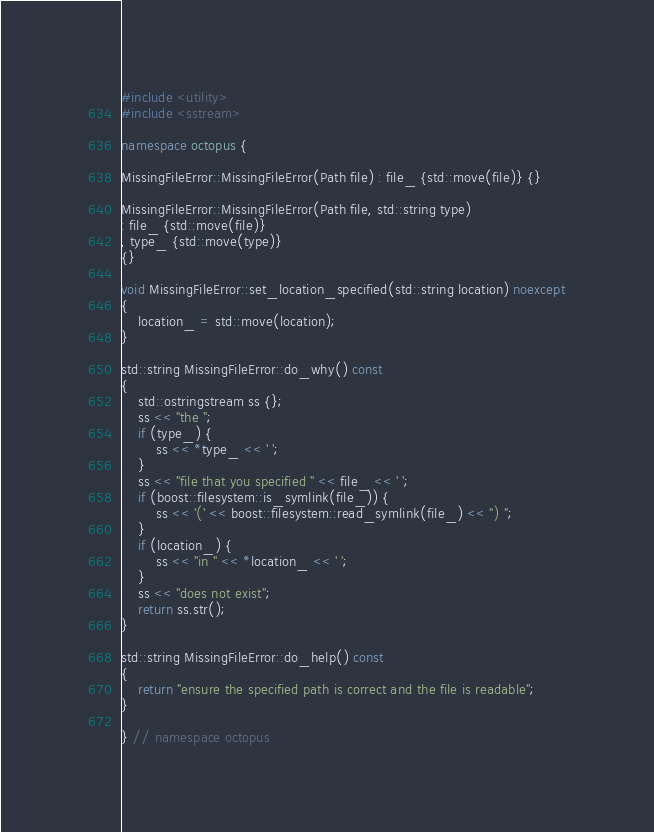Convert code to text. <code><loc_0><loc_0><loc_500><loc_500><_C++_>#include <utility>
#include <sstream>

namespace octopus {

MissingFileError::MissingFileError(Path file) : file_ {std::move(file)} {}

MissingFileError::MissingFileError(Path file, std::string type)
: file_ {std::move(file)}
, type_ {std::move(type)}
{}

void MissingFileError::set_location_specified(std::string location) noexcept
{
    location_ = std::move(location);
}

std::string MissingFileError::do_why() const
{
    std::ostringstream ss {};
    ss << "the ";
    if (type_) {
        ss << *type_ << ' ';
    }
    ss << "file that you specified " << file_ << ' ';
    if (boost::filesystem::is_symlink(file_)) {
        ss << '(' << boost::filesystem::read_symlink(file_) << ") ";
    }
    if (location_) {
        ss << "in " << *location_ << ' ';
    }
    ss << "does not exist";
    return ss.str();
}

std::string MissingFileError::do_help() const
{
    return "ensure the specified path is correct and the file is readable";
}

} // namespace octopus
</code> 